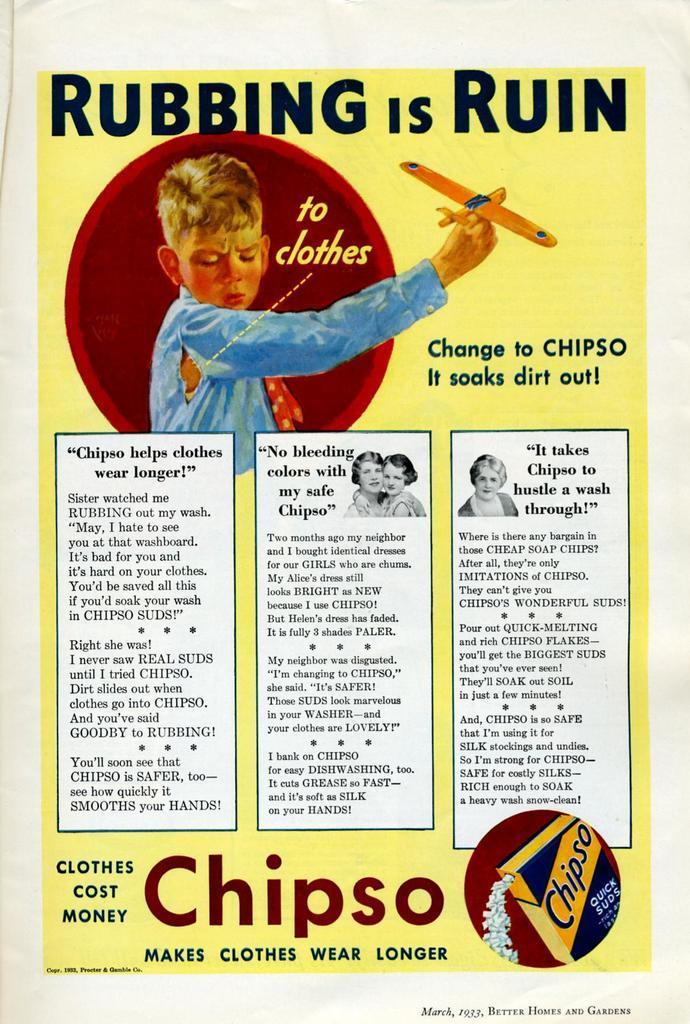<image>
Summarize the visual content of the image. A poster with a boy playing with a model airplane says Rubbing is Ruin. 